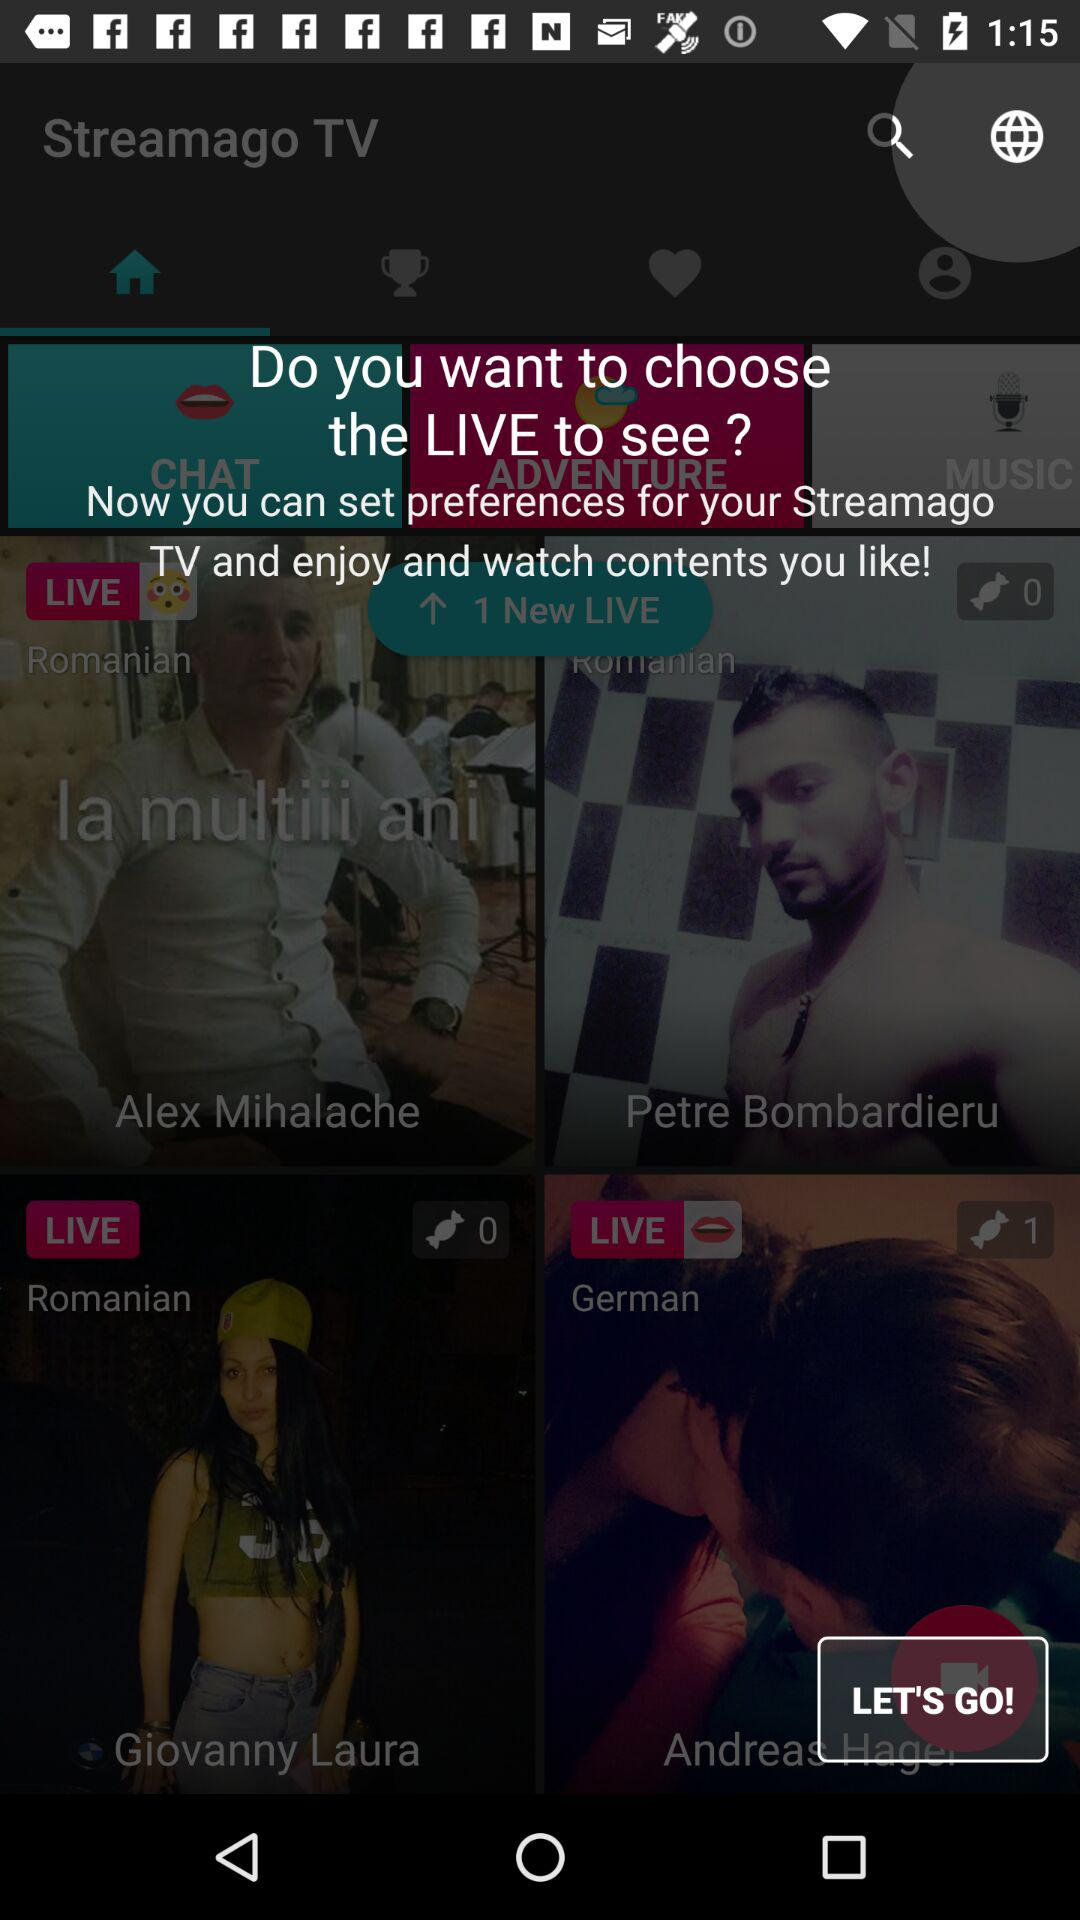How many live streams are there in total?
Answer the question using a single word or phrase. 3 